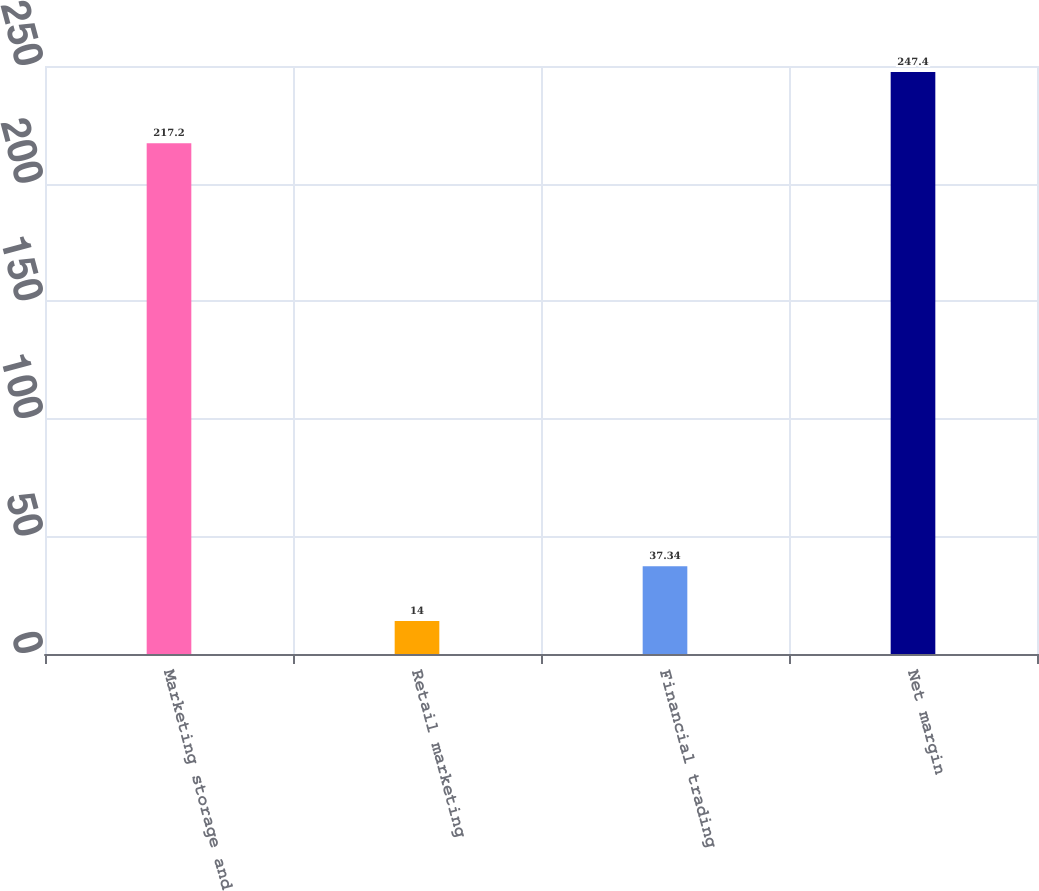<chart> <loc_0><loc_0><loc_500><loc_500><bar_chart><fcel>Marketing storage and<fcel>Retail marketing<fcel>Financial trading<fcel>Net margin<nl><fcel>217.2<fcel>14<fcel>37.34<fcel>247.4<nl></chart> 